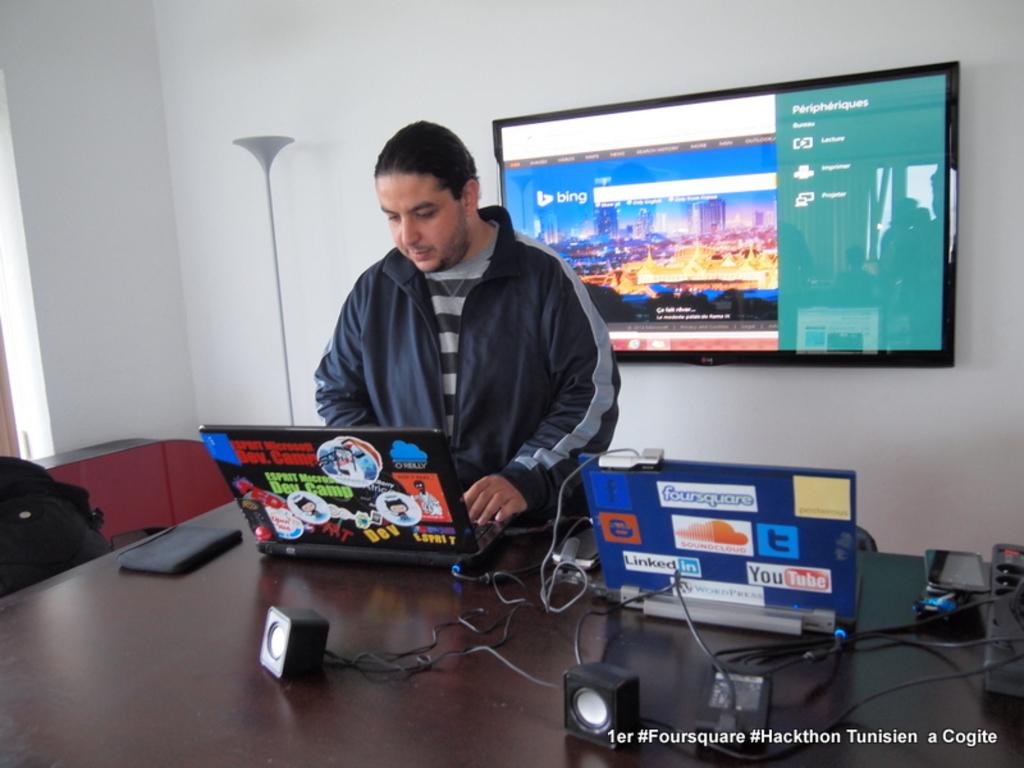What search engine is up on the tv on the wall?
Ensure brevity in your answer.  Bing. What is the logo in white on the laptop?
Give a very brief answer. Foursquare. 